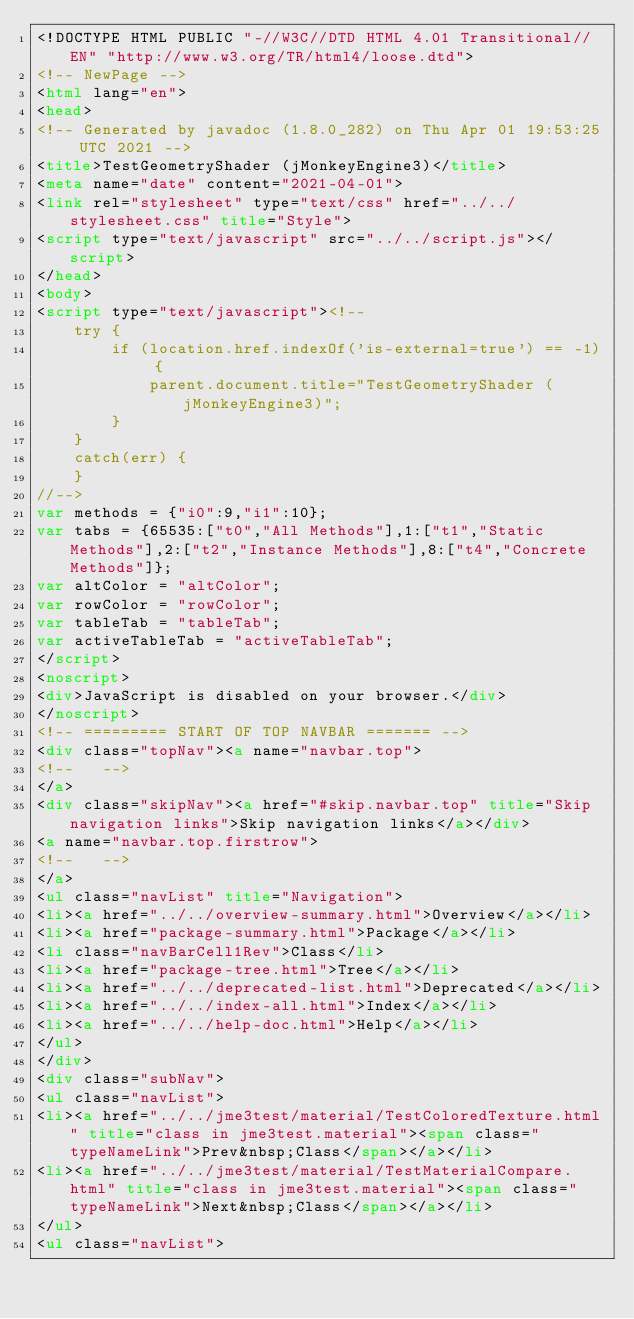Convert code to text. <code><loc_0><loc_0><loc_500><loc_500><_HTML_><!DOCTYPE HTML PUBLIC "-//W3C//DTD HTML 4.01 Transitional//EN" "http://www.w3.org/TR/html4/loose.dtd">
<!-- NewPage -->
<html lang="en">
<head>
<!-- Generated by javadoc (1.8.0_282) on Thu Apr 01 19:53:25 UTC 2021 -->
<title>TestGeometryShader (jMonkeyEngine3)</title>
<meta name="date" content="2021-04-01">
<link rel="stylesheet" type="text/css" href="../../stylesheet.css" title="Style">
<script type="text/javascript" src="../../script.js"></script>
</head>
<body>
<script type="text/javascript"><!--
    try {
        if (location.href.indexOf('is-external=true') == -1) {
            parent.document.title="TestGeometryShader (jMonkeyEngine3)";
        }
    }
    catch(err) {
    }
//-->
var methods = {"i0":9,"i1":10};
var tabs = {65535:["t0","All Methods"],1:["t1","Static Methods"],2:["t2","Instance Methods"],8:["t4","Concrete Methods"]};
var altColor = "altColor";
var rowColor = "rowColor";
var tableTab = "tableTab";
var activeTableTab = "activeTableTab";
</script>
<noscript>
<div>JavaScript is disabled on your browser.</div>
</noscript>
<!-- ========= START OF TOP NAVBAR ======= -->
<div class="topNav"><a name="navbar.top">
<!--   -->
</a>
<div class="skipNav"><a href="#skip.navbar.top" title="Skip navigation links">Skip navigation links</a></div>
<a name="navbar.top.firstrow">
<!--   -->
</a>
<ul class="navList" title="Navigation">
<li><a href="../../overview-summary.html">Overview</a></li>
<li><a href="package-summary.html">Package</a></li>
<li class="navBarCell1Rev">Class</li>
<li><a href="package-tree.html">Tree</a></li>
<li><a href="../../deprecated-list.html">Deprecated</a></li>
<li><a href="../../index-all.html">Index</a></li>
<li><a href="../../help-doc.html">Help</a></li>
</ul>
</div>
<div class="subNav">
<ul class="navList">
<li><a href="../../jme3test/material/TestColoredTexture.html" title="class in jme3test.material"><span class="typeNameLink">Prev&nbsp;Class</span></a></li>
<li><a href="../../jme3test/material/TestMaterialCompare.html" title="class in jme3test.material"><span class="typeNameLink">Next&nbsp;Class</span></a></li>
</ul>
<ul class="navList"></code> 